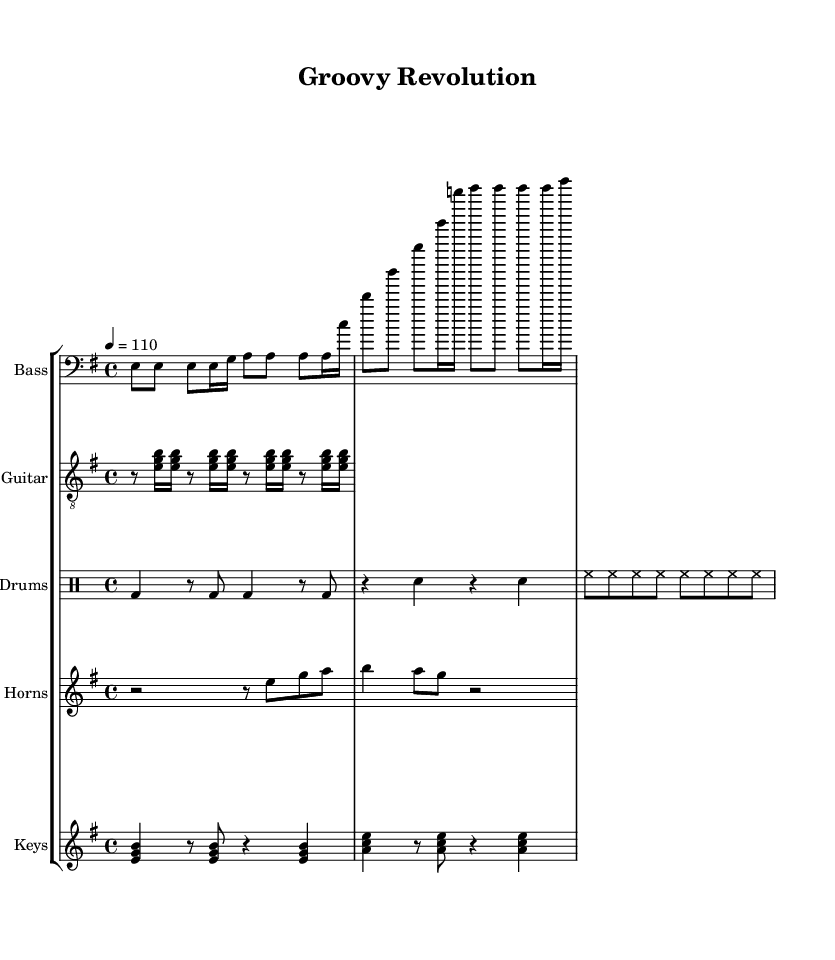What is the key signature of this music? The key signature is E minor, which has one sharp. The symbol for the sharp (F#) is indicated in the key signature on the left side of the staff.
Answer: E minor What is the time signature of the score? The time signature is 4/4, which is indicated at the beginning of the score. It means there are four beats in a measure and the quarter note gets one beat.
Answer: 4/4 What is the tempo marking of the piece? The tempo marking is 110 beats per minute, as defined at the beginning of the score. This indicates the speed at which the piece should be played.
Answer: 110 How many measures are in the drum pattern? The drum pattern consists of four measures, as counted between the double vertical lines indicating the end of each measure. Each grouping of beats within these lines counts as one measure.
Answer: 4 Which instruments comprise the score? The score includes bass, guitar, drums, horns, and keys. These are clearly labeled on their respective staves at the beginning of the score.
Answer: Bass, guitar, drums, horns, keys What is the rhythmic value of the notes used in the bass line? The rhythmic values in the bass line include eighth notes and sixteenth notes. The eighth notes are represented as 'e', while the sixteenth notes are notated with a '16' following the note.
Answer: Eighth notes and sixteenth notes Which musical genre does this piece belong to? This piece belongs to the Funk genre, which is characterized by its strong rhythmic groove and was prominent in the 1960s counterculture. The musical structure reflects the elements typical of Funk music, such as syncopation and a deep groove.
Answer: Funk 